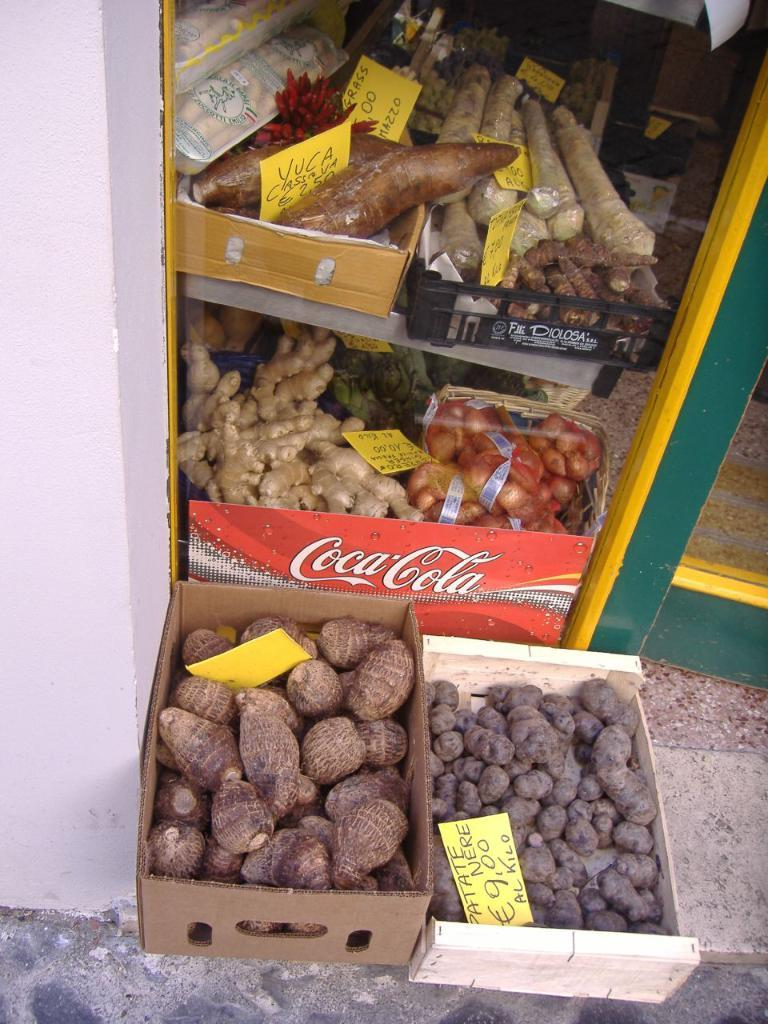What type of food items are in the cardboard boxes in the image? There are vegetables in the cardboard boxes in the image. What color are the boards in the image? The boards in the image are yellow-colored. What color is the wall in the image? The wall in the image is white. What type of treatment is being administered to the vegetables in the image? There is no treatment being administered to the vegetables in the image; they are simply in cardboard boxes. In which direction does the image face, north or south? The image does not have a specific direction, so it cannot be determined if it faces north or south. 